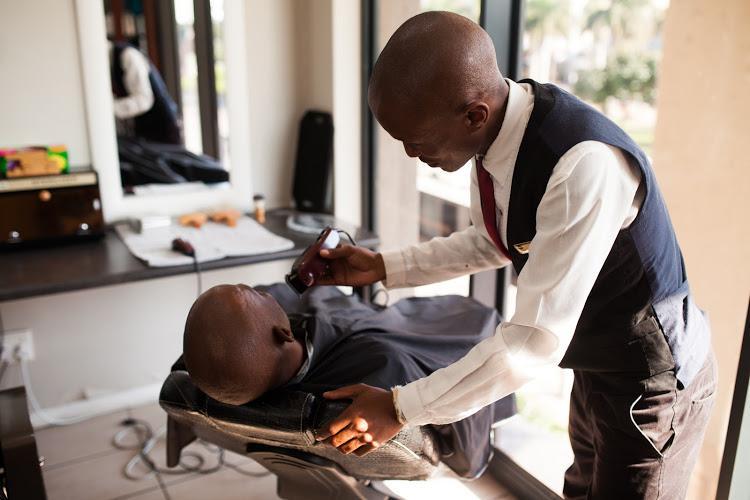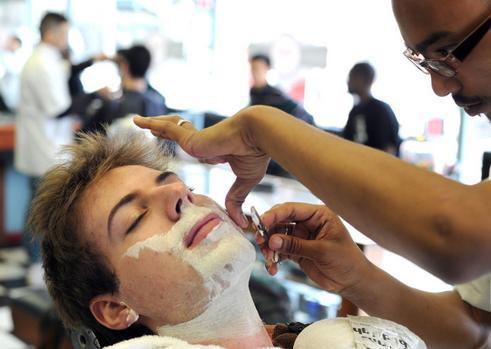The first image is the image on the left, the second image is the image on the right. Given the left and right images, does the statement "Barber stylists stand with their arms crossed in one image, while a patron receives a barbershop service in the other image." hold true? Answer yes or no. No. The first image is the image on the left, the second image is the image on the right. Evaluate the accuracy of this statement regarding the images: "One image shows hair stylists posing with folded arms, without customers.". Is it true? Answer yes or no. No. 